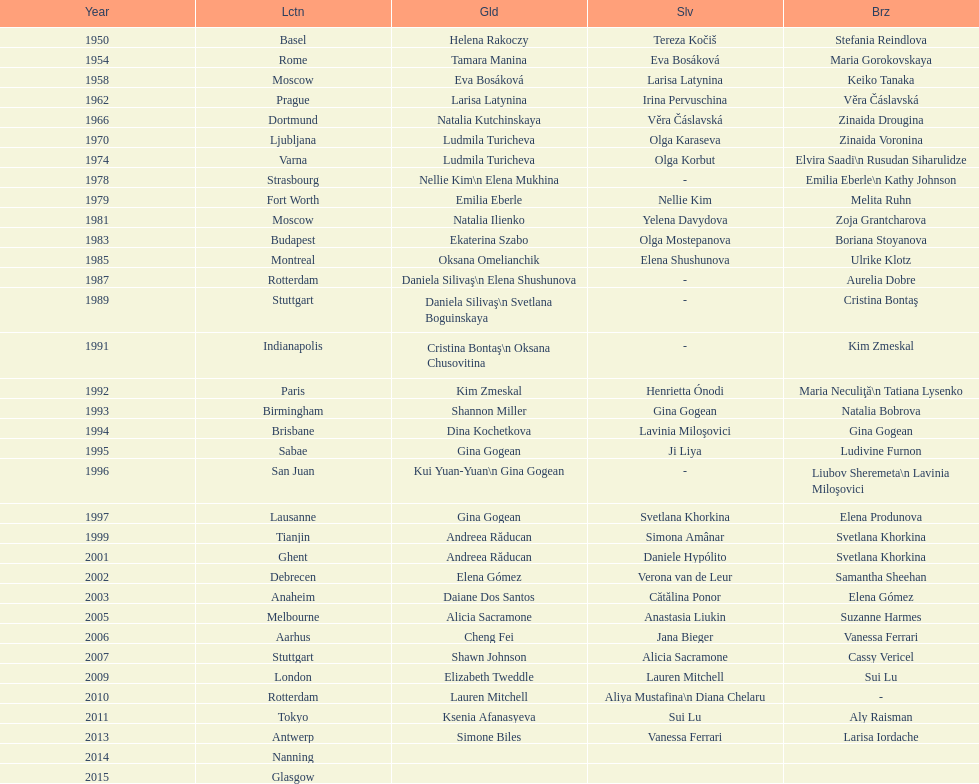How many consecutive floor exercise gold medals did romanian star andreea raducan win at the world championships? 2. 